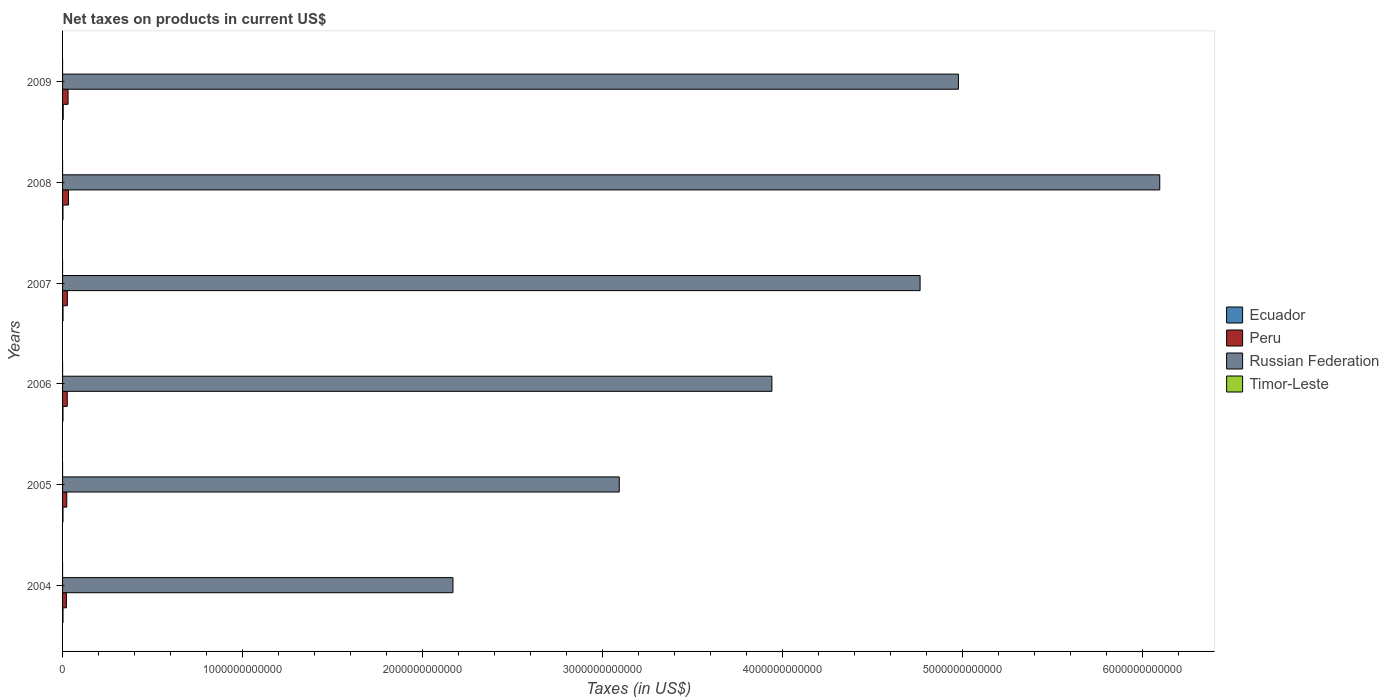How many different coloured bars are there?
Provide a succinct answer. 4. Are the number of bars per tick equal to the number of legend labels?
Give a very brief answer. No. How many bars are there on the 4th tick from the top?
Offer a very short reply. 3. How many bars are there on the 1st tick from the bottom?
Provide a short and direct response. 4. In how many cases, is the number of bars for a given year not equal to the number of legend labels?
Keep it short and to the point. 3. What is the net taxes on products in Ecuador in 2008?
Provide a short and direct response. 2.21e+09. Across all years, what is the maximum net taxes on products in Timor-Leste?
Provide a succinct answer. 1.60e+07. Across all years, what is the minimum net taxes on products in Russian Federation?
Offer a very short reply. 2.17e+12. What is the total net taxes on products in Timor-Leste in the graph?
Ensure brevity in your answer.  3.70e+07. What is the difference between the net taxes on products in Russian Federation in 2004 and that in 2007?
Your answer should be very brief. -2.59e+12. What is the difference between the net taxes on products in Peru in 2004 and the net taxes on products in Ecuador in 2009?
Provide a succinct answer. 1.78e+1. What is the average net taxes on products in Ecuador per year?
Provide a succinct answer. 2.54e+09. In the year 2005, what is the difference between the net taxes on products in Ecuador and net taxes on products in Russian Federation?
Provide a succinct answer. -3.09e+12. In how many years, is the net taxes on products in Russian Federation greater than 6000000000000 US$?
Ensure brevity in your answer.  1. What is the ratio of the net taxes on products in Ecuador in 2006 to that in 2009?
Give a very brief answer. 0.66. What is the difference between the highest and the lowest net taxes on products in Ecuador?
Make the answer very short. 1.29e+09. Is it the case that in every year, the sum of the net taxes on products in Peru and net taxes on products in Russian Federation is greater than the net taxes on products in Ecuador?
Provide a short and direct response. Yes. How many bars are there?
Provide a short and direct response. 21. Are all the bars in the graph horizontal?
Provide a short and direct response. Yes. What is the difference between two consecutive major ticks on the X-axis?
Keep it short and to the point. 1.00e+12. Does the graph contain grids?
Keep it short and to the point. No. How many legend labels are there?
Your response must be concise. 4. How are the legend labels stacked?
Your answer should be very brief. Vertical. What is the title of the graph?
Your answer should be very brief. Net taxes on products in current US$. What is the label or title of the X-axis?
Give a very brief answer. Taxes (in US$). What is the Taxes (in US$) in Ecuador in 2004?
Provide a short and direct response. 2.39e+09. What is the Taxes (in US$) of Peru in 2004?
Give a very brief answer. 2.13e+1. What is the Taxes (in US$) of Russian Federation in 2004?
Offer a terse response. 2.17e+12. What is the Taxes (in US$) of Timor-Leste in 2004?
Provide a succinct answer. 1.60e+07. What is the Taxes (in US$) of Ecuador in 2005?
Keep it short and to the point. 2.30e+09. What is the Taxes (in US$) of Peru in 2005?
Your response must be concise. 2.33e+1. What is the Taxes (in US$) in Russian Federation in 2005?
Keep it short and to the point. 3.09e+12. What is the Taxes (in US$) in Timor-Leste in 2005?
Offer a terse response. 1.20e+07. What is the Taxes (in US$) of Ecuador in 2006?
Your answer should be very brief. 2.30e+09. What is the Taxes (in US$) of Peru in 2006?
Your answer should be compact. 2.60e+1. What is the Taxes (in US$) of Russian Federation in 2006?
Offer a terse response. 3.94e+12. What is the Taxes (in US$) of Ecuador in 2007?
Provide a succinct answer. 2.50e+09. What is the Taxes (in US$) of Peru in 2007?
Make the answer very short. 2.65e+1. What is the Taxes (in US$) of Russian Federation in 2007?
Offer a terse response. 4.76e+12. What is the Taxes (in US$) of Timor-Leste in 2007?
Give a very brief answer. 9.00e+06. What is the Taxes (in US$) of Ecuador in 2008?
Offer a very short reply. 2.21e+09. What is the Taxes (in US$) in Peru in 2008?
Give a very brief answer. 3.29e+1. What is the Taxes (in US$) in Russian Federation in 2008?
Your answer should be very brief. 6.09e+12. What is the Taxes (in US$) in Timor-Leste in 2008?
Your answer should be very brief. 0. What is the Taxes (in US$) of Ecuador in 2009?
Give a very brief answer. 3.51e+09. What is the Taxes (in US$) of Peru in 2009?
Offer a very short reply. 3.05e+1. What is the Taxes (in US$) in Russian Federation in 2009?
Offer a terse response. 4.98e+12. What is the Taxes (in US$) in Timor-Leste in 2009?
Your answer should be very brief. 0. Across all years, what is the maximum Taxes (in US$) in Ecuador?
Keep it short and to the point. 3.51e+09. Across all years, what is the maximum Taxes (in US$) of Peru?
Provide a succinct answer. 3.29e+1. Across all years, what is the maximum Taxes (in US$) in Russian Federation?
Provide a short and direct response. 6.09e+12. Across all years, what is the maximum Taxes (in US$) of Timor-Leste?
Keep it short and to the point. 1.60e+07. Across all years, what is the minimum Taxes (in US$) in Ecuador?
Provide a short and direct response. 2.21e+09. Across all years, what is the minimum Taxes (in US$) of Peru?
Your response must be concise. 2.13e+1. Across all years, what is the minimum Taxes (in US$) in Russian Federation?
Your answer should be compact. 2.17e+12. What is the total Taxes (in US$) of Ecuador in the graph?
Make the answer very short. 1.52e+1. What is the total Taxes (in US$) of Peru in the graph?
Make the answer very short. 1.61e+11. What is the total Taxes (in US$) of Russian Federation in the graph?
Offer a terse response. 2.50e+13. What is the total Taxes (in US$) of Timor-Leste in the graph?
Offer a very short reply. 3.70e+07. What is the difference between the Taxes (in US$) of Ecuador in 2004 and that in 2005?
Your answer should be very brief. 9.16e+07. What is the difference between the Taxes (in US$) of Peru in 2004 and that in 2005?
Your answer should be compact. -1.97e+09. What is the difference between the Taxes (in US$) of Russian Federation in 2004 and that in 2005?
Ensure brevity in your answer.  -9.24e+11. What is the difference between the Taxes (in US$) in Timor-Leste in 2004 and that in 2005?
Give a very brief answer. 4.00e+06. What is the difference between the Taxes (in US$) in Ecuador in 2004 and that in 2006?
Give a very brief answer. 8.86e+07. What is the difference between the Taxes (in US$) of Peru in 2004 and that in 2006?
Give a very brief answer. -4.66e+09. What is the difference between the Taxes (in US$) in Russian Federation in 2004 and that in 2006?
Your answer should be very brief. -1.77e+12. What is the difference between the Taxes (in US$) of Ecuador in 2004 and that in 2007?
Ensure brevity in your answer.  -1.03e+08. What is the difference between the Taxes (in US$) in Peru in 2004 and that in 2007?
Offer a terse response. -5.16e+09. What is the difference between the Taxes (in US$) in Russian Federation in 2004 and that in 2007?
Offer a terse response. -2.59e+12. What is the difference between the Taxes (in US$) in Ecuador in 2004 and that in 2008?
Offer a very short reply. 1.82e+08. What is the difference between the Taxes (in US$) of Peru in 2004 and that in 2008?
Give a very brief answer. -1.16e+1. What is the difference between the Taxes (in US$) of Russian Federation in 2004 and that in 2008?
Offer a terse response. -3.93e+12. What is the difference between the Taxes (in US$) in Ecuador in 2004 and that in 2009?
Offer a terse response. -1.11e+09. What is the difference between the Taxes (in US$) in Peru in 2004 and that in 2009?
Provide a short and direct response. -9.16e+09. What is the difference between the Taxes (in US$) in Russian Federation in 2004 and that in 2009?
Give a very brief answer. -2.81e+12. What is the difference between the Taxes (in US$) of Ecuador in 2005 and that in 2006?
Give a very brief answer. -2.96e+06. What is the difference between the Taxes (in US$) in Peru in 2005 and that in 2006?
Your answer should be compact. -2.69e+09. What is the difference between the Taxes (in US$) of Russian Federation in 2005 and that in 2006?
Offer a terse response. -8.48e+11. What is the difference between the Taxes (in US$) of Ecuador in 2005 and that in 2007?
Ensure brevity in your answer.  -1.95e+08. What is the difference between the Taxes (in US$) of Peru in 2005 and that in 2007?
Make the answer very short. -3.19e+09. What is the difference between the Taxes (in US$) of Russian Federation in 2005 and that in 2007?
Ensure brevity in your answer.  -1.67e+12. What is the difference between the Taxes (in US$) of Ecuador in 2005 and that in 2008?
Make the answer very short. 9.02e+07. What is the difference between the Taxes (in US$) of Peru in 2005 and that in 2008?
Keep it short and to the point. -9.61e+09. What is the difference between the Taxes (in US$) of Russian Federation in 2005 and that in 2008?
Offer a very short reply. -3.00e+12. What is the difference between the Taxes (in US$) in Ecuador in 2005 and that in 2009?
Make the answer very short. -1.20e+09. What is the difference between the Taxes (in US$) of Peru in 2005 and that in 2009?
Your answer should be compact. -7.19e+09. What is the difference between the Taxes (in US$) of Russian Federation in 2005 and that in 2009?
Keep it short and to the point. -1.88e+12. What is the difference between the Taxes (in US$) in Ecuador in 2006 and that in 2007?
Give a very brief answer. -1.92e+08. What is the difference between the Taxes (in US$) in Peru in 2006 and that in 2007?
Your answer should be very brief. -4.99e+08. What is the difference between the Taxes (in US$) in Russian Federation in 2006 and that in 2007?
Offer a terse response. -8.23e+11. What is the difference between the Taxes (in US$) in Ecuador in 2006 and that in 2008?
Ensure brevity in your answer.  9.32e+07. What is the difference between the Taxes (in US$) of Peru in 2006 and that in 2008?
Your response must be concise. -6.92e+09. What is the difference between the Taxes (in US$) of Russian Federation in 2006 and that in 2008?
Your answer should be very brief. -2.15e+12. What is the difference between the Taxes (in US$) in Ecuador in 2006 and that in 2009?
Make the answer very short. -1.20e+09. What is the difference between the Taxes (in US$) in Peru in 2006 and that in 2009?
Offer a very short reply. -4.50e+09. What is the difference between the Taxes (in US$) in Russian Federation in 2006 and that in 2009?
Offer a terse response. -1.04e+12. What is the difference between the Taxes (in US$) of Ecuador in 2007 and that in 2008?
Provide a short and direct response. 2.85e+08. What is the difference between the Taxes (in US$) of Peru in 2007 and that in 2008?
Keep it short and to the point. -6.42e+09. What is the difference between the Taxes (in US$) of Russian Federation in 2007 and that in 2008?
Offer a very short reply. -1.33e+12. What is the difference between the Taxes (in US$) of Ecuador in 2007 and that in 2009?
Your response must be concise. -1.01e+09. What is the difference between the Taxes (in US$) of Peru in 2007 and that in 2009?
Your response must be concise. -4.00e+09. What is the difference between the Taxes (in US$) in Russian Federation in 2007 and that in 2009?
Your answer should be compact. -2.13e+11. What is the difference between the Taxes (in US$) in Ecuador in 2008 and that in 2009?
Your answer should be compact. -1.29e+09. What is the difference between the Taxes (in US$) of Peru in 2008 and that in 2009?
Offer a very short reply. 2.42e+09. What is the difference between the Taxes (in US$) of Russian Federation in 2008 and that in 2009?
Keep it short and to the point. 1.12e+12. What is the difference between the Taxes (in US$) of Ecuador in 2004 and the Taxes (in US$) of Peru in 2005?
Provide a succinct answer. -2.09e+1. What is the difference between the Taxes (in US$) in Ecuador in 2004 and the Taxes (in US$) in Russian Federation in 2005?
Give a very brief answer. -3.09e+12. What is the difference between the Taxes (in US$) in Ecuador in 2004 and the Taxes (in US$) in Timor-Leste in 2005?
Give a very brief answer. 2.38e+09. What is the difference between the Taxes (in US$) of Peru in 2004 and the Taxes (in US$) of Russian Federation in 2005?
Provide a succinct answer. -3.07e+12. What is the difference between the Taxes (in US$) of Peru in 2004 and the Taxes (in US$) of Timor-Leste in 2005?
Make the answer very short. 2.13e+1. What is the difference between the Taxes (in US$) in Russian Federation in 2004 and the Taxes (in US$) in Timor-Leste in 2005?
Make the answer very short. 2.17e+12. What is the difference between the Taxes (in US$) in Ecuador in 2004 and the Taxes (in US$) in Peru in 2006?
Give a very brief answer. -2.36e+1. What is the difference between the Taxes (in US$) of Ecuador in 2004 and the Taxes (in US$) of Russian Federation in 2006?
Your response must be concise. -3.94e+12. What is the difference between the Taxes (in US$) in Peru in 2004 and the Taxes (in US$) in Russian Federation in 2006?
Provide a short and direct response. -3.92e+12. What is the difference between the Taxes (in US$) of Ecuador in 2004 and the Taxes (in US$) of Peru in 2007?
Provide a succinct answer. -2.41e+1. What is the difference between the Taxes (in US$) in Ecuador in 2004 and the Taxes (in US$) in Russian Federation in 2007?
Provide a succinct answer. -4.76e+12. What is the difference between the Taxes (in US$) in Ecuador in 2004 and the Taxes (in US$) in Timor-Leste in 2007?
Offer a very short reply. 2.38e+09. What is the difference between the Taxes (in US$) in Peru in 2004 and the Taxes (in US$) in Russian Federation in 2007?
Your answer should be very brief. -4.74e+12. What is the difference between the Taxes (in US$) in Peru in 2004 and the Taxes (in US$) in Timor-Leste in 2007?
Offer a very short reply. 2.13e+1. What is the difference between the Taxes (in US$) in Russian Federation in 2004 and the Taxes (in US$) in Timor-Leste in 2007?
Make the answer very short. 2.17e+12. What is the difference between the Taxes (in US$) of Ecuador in 2004 and the Taxes (in US$) of Peru in 2008?
Keep it short and to the point. -3.05e+1. What is the difference between the Taxes (in US$) of Ecuador in 2004 and the Taxes (in US$) of Russian Federation in 2008?
Your response must be concise. -6.09e+12. What is the difference between the Taxes (in US$) in Peru in 2004 and the Taxes (in US$) in Russian Federation in 2008?
Your response must be concise. -6.07e+12. What is the difference between the Taxes (in US$) of Ecuador in 2004 and the Taxes (in US$) of Peru in 2009?
Provide a succinct answer. -2.81e+1. What is the difference between the Taxes (in US$) in Ecuador in 2004 and the Taxes (in US$) in Russian Federation in 2009?
Provide a succinct answer. -4.97e+12. What is the difference between the Taxes (in US$) of Peru in 2004 and the Taxes (in US$) of Russian Federation in 2009?
Your answer should be compact. -4.95e+12. What is the difference between the Taxes (in US$) of Ecuador in 2005 and the Taxes (in US$) of Peru in 2006?
Provide a short and direct response. -2.37e+1. What is the difference between the Taxes (in US$) in Ecuador in 2005 and the Taxes (in US$) in Russian Federation in 2006?
Provide a succinct answer. -3.94e+12. What is the difference between the Taxes (in US$) of Peru in 2005 and the Taxes (in US$) of Russian Federation in 2006?
Your answer should be very brief. -3.92e+12. What is the difference between the Taxes (in US$) of Ecuador in 2005 and the Taxes (in US$) of Peru in 2007?
Provide a succinct answer. -2.42e+1. What is the difference between the Taxes (in US$) of Ecuador in 2005 and the Taxes (in US$) of Russian Federation in 2007?
Give a very brief answer. -4.76e+12. What is the difference between the Taxes (in US$) of Ecuador in 2005 and the Taxes (in US$) of Timor-Leste in 2007?
Give a very brief answer. 2.29e+09. What is the difference between the Taxes (in US$) in Peru in 2005 and the Taxes (in US$) in Russian Federation in 2007?
Make the answer very short. -4.74e+12. What is the difference between the Taxes (in US$) in Peru in 2005 and the Taxes (in US$) in Timor-Leste in 2007?
Provide a short and direct response. 2.33e+1. What is the difference between the Taxes (in US$) in Russian Federation in 2005 and the Taxes (in US$) in Timor-Leste in 2007?
Offer a terse response. 3.09e+12. What is the difference between the Taxes (in US$) of Ecuador in 2005 and the Taxes (in US$) of Peru in 2008?
Offer a very short reply. -3.06e+1. What is the difference between the Taxes (in US$) of Ecuador in 2005 and the Taxes (in US$) of Russian Federation in 2008?
Make the answer very short. -6.09e+12. What is the difference between the Taxes (in US$) in Peru in 2005 and the Taxes (in US$) in Russian Federation in 2008?
Offer a very short reply. -6.07e+12. What is the difference between the Taxes (in US$) of Ecuador in 2005 and the Taxes (in US$) of Peru in 2009?
Ensure brevity in your answer.  -2.82e+1. What is the difference between the Taxes (in US$) in Ecuador in 2005 and the Taxes (in US$) in Russian Federation in 2009?
Your answer should be compact. -4.97e+12. What is the difference between the Taxes (in US$) of Peru in 2005 and the Taxes (in US$) of Russian Federation in 2009?
Keep it short and to the point. -4.95e+12. What is the difference between the Taxes (in US$) in Ecuador in 2006 and the Taxes (in US$) in Peru in 2007?
Your answer should be compact. -2.42e+1. What is the difference between the Taxes (in US$) in Ecuador in 2006 and the Taxes (in US$) in Russian Federation in 2007?
Ensure brevity in your answer.  -4.76e+12. What is the difference between the Taxes (in US$) in Ecuador in 2006 and the Taxes (in US$) in Timor-Leste in 2007?
Make the answer very short. 2.30e+09. What is the difference between the Taxes (in US$) of Peru in 2006 and the Taxes (in US$) of Russian Federation in 2007?
Your answer should be compact. -4.74e+12. What is the difference between the Taxes (in US$) in Peru in 2006 and the Taxes (in US$) in Timor-Leste in 2007?
Keep it short and to the point. 2.60e+1. What is the difference between the Taxes (in US$) in Russian Federation in 2006 and the Taxes (in US$) in Timor-Leste in 2007?
Make the answer very short. 3.94e+12. What is the difference between the Taxes (in US$) of Ecuador in 2006 and the Taxes (in US$) of Peru in 2008?
Your answer should be compact. -3.06e+1. What is the difference between the Taxes (in US$) in Ecuador in 2006 and the Taxes (in US$) in Russian Federation in 2008?
Your response must be concise. -6.09e+12. What is the difference between the Taxes (in US$) of Peru in 2006 and the Taxes (in US$) of Russian Federation in 2008?
Provide a short and direct response. -6.07e+12. What is the difference between the Taxes (in US$) of Ecuador in 2006 and the Taxes (in US$) of Peru in 2009?
Offer a very short reply. -2.82e+1. What is the difference between the Taxes (in US$) in Ecuador in 2006 and the Taxes (in US$) in Russian Federation in 2009?
Keep it short and to the point. -4.97e+12. What is the difference between the Taxes (in US$) of Peru in 2006 and the Taxes (in US$) of Russian Federation in 2009?
Your answer should be compact. -4.95e+12. What is the difference between the Taxes (in US$) in Ecuador in 2007 and the Taxes (in US$) in Peru in 2008?
Your response must be concise. -3.04e+1. What is the difference between the Taxes (in US$) in Ecuador in 2007 and the Taxes (in US$) in Russian Federation in 2008?
Ensure brevity in your answer.  -6.09e+12. What is the difference between the Taxes (in US$) of Peru in 2007 and the Taxes (in US$) of Russian Federation in 2008?
Your response must be concise. -6.07e+12. What is the difference between the Taxes (in US$) in Ecuador in 2007 and the Taxes (in US$) in Peru in 2009?
Ensure brevity in your answer.  -2.80e+1. What is the difference between the Taxes (in US$) of Ecuador in 2007 and the Taxes (in US$) of Russian Federation in 2009?
Your response must be concise. -4.97e+12. What is the difference between the Taxes (in US$) in Peru in 2007 and the Taxes (in US$) in Russian Federation in 2009?
Give a very brief answer. -4.95e+12. What is the difference between the Taxes (in US$) in Ecuador in 2008 and the Taxes (in US$) in Peru in 2009?
Your answer should be compact. -2.83e+1. What is the difference between the Taxes (in US$) of Ecuador in 2008 and the Taxes (in US$) of Russian Federation in 2009?
Give a very brief answer. -4.97e+12. What is the difference between the Taxes (in US$) of Peru in 2008 and the Taxes (in US$) of Russian Federation in 2009?
Offer a very short reply. -4.94e+12. What is the average Taxes (in US$) in Ecuador per year?
Make the answer very short. 2.54e+09. What is the average Taxes (in US$) in Peru per year?
Provide a succinct answer. 2.68e+1. What is the average Taxes (in US$) in Russian Federation per year?
Provide a succinct answer. 4.17e+12. What is the average Taxes (in US$) in Timor-Leste per year?
Offer a very short reply. 6.17e+06. In the year 2004, what is the difference between the Taxes (in US$) in Ecuador and Taxes (in US$) in Peru?
Give a very brief answer. -1.90e+1. In the year 2004, what is the difference between the Taxes (in US$) in Ecuador and Taxes (in US$) in Russian Federation?
Your response must be concise. -2.17e+12. In the year 2004, what is the difference between the Taxes (in US$) in Ecuador and Taxes (in US$) in Timor-Leste?
Make the answer very short. 2.38e+09. In the year 2004, what is the difference between the Taxes (in US$) of Peru and Taxes (in US$) of Russian Federation?
Make the answer very short. -2.15e+12. In the year 2004, what is the difference between the Taxes (in US$) of Peru and Taxes (in US$) of Timor-Leste?
Keep it short and to the point. 2.13e+1. In the year 2004, what is the difference between the Taxes (in US$) of Russian Federation and Taxes (in US$) of Timor-Leste?
Ensure brevity in your answer.  2.17e+12. In the year 2005, what is the difference between the Taxes (in US$) in Ecuador and Taxes (in US$) in Peru?
Your answer should be very brief. -2.10e+1. In the year 2005, what is the difference between the Taxes (in US$) in Ecuador and Taxes (in US$) in Russian Federation?
Make the answer very short. -3.09e+12. In the year 2005, what is the difference between the Taxes (in US$) of Ecuador and Taxes (in US$) of Timor-Leste?
Offer a very short reply. 2.29e+09. In the year 2005, what is the difference between the Taxes (in US$) of Peru and Taxes (in US$) of Russian Federation?
Keep it short and to the point. -3.07e+12. In the year 2005, what is the difference between the Taxes (in US$) of Peru and Taxes (in US$) of Timor-Leste?
Offer a terse response. 2.33e+1. In the year 2005, what is the difference between the Taxes (in US$) in Russian Federation and Taxes (in US$) in Timor-Leste?
Provide a succinct answer. 3.09e+12. In the year 2006, what is the difference between the Taxes (in US$) in Ecuador and Taxes (in US$) in Peru?
Keep it short and to the point. -2.37e+1. In the year 2006, what is the difference between the Taxes (in US$) in Ecuador and Taxes (in US$) in Russian Federation?
Provide a short and direct response. -3.94e+12. In the year 2006, what is the difference between the Taxes (in US$) in Peru and Taxes (in US$) in Russian Federation?
Provide a succinct answer. -3.91e+12. In the year 2007, what is the difference between the Taxes (in US$) of Ecuador and Taxes (in US$) of Peru?
Your response must be concise. -2.40e+1. In the year 2007, what is the difference between the Taxes (in US$) in Ecuador and Taxes (in US$) in Russian Federation?
Your answer should be very brief. -4.76e+12. In the year 2007, what is the difference between the Taxes (in US$) of Ecuador and Taxes (in US$) of Timor-Leste?
Ensure brevity in your answer.  2.49e+09. In the year 2007, what is the difference between the Taxes (in US$) of Peru and Taxes (in US$) of Russian Federation?
Offer a very short reply. -4.74e+12. In the year 2007, what is the difference between the Taxes (in US$) in Peru and Taxes (in US$) in Timor-Leste?
Provide a succinct answer. 2.65e+1. In the year 2007, what is the difference between the Taxes (in US$) in Russian Federation and Taxes (in US$) in Timor-Leste?
Provide a succinct answer. 4.76e+12. In the year 2008, what is the difference between the Taxes (in US$) of Ecuador and Taxes (in US$) of Peru?
Keep it short and to the point. -3.07e+1. In the year 2008, what is the difference between the Taxes (in US$) in Ecuador and Taxes (in US$) in Russian Federation?
Your response must be concise. -6.09e+12. In the year 2008, what is the difference between the Taxes (in US$) in Peru and Taxes (in US$) in Russian Federation?
Offer a very short reply. -6.06e+12. In the year 2009, what is the difference between the Taxes (in US$) in Ecuador and Taxes (in US$) in Peru?
Your answer should be compact. -2.70e+1. In the year 2009, what is the difference between the Taxes (in US$) in Ecuador and Taxes (in US$) in Russian Federation?
Give a very brief answer. -4.97e+12. In the year 2009, what is the difference between the Taxes (in US$) of Peru and Taxes (in US$) of Russian Federation?
Your response must be concise. -4.95e+12. What is the ratio of the Taxes (in US$) of Ecuador in 2004 to that in 2005?
Provide a succinct answer. 1.04. What is the ratio of the Taxes (in US$) of Peru in 2004 to that in 2005?
Your response must be concise. 0.92. What is the ratio of the Taxes (in US$) of Russian Federation in 2004 to that in 2005?
Provide a succinct answer. 0.7. What is the ratio of the Taxes (in US$) of Timor-Leste in 2004 to that in 2005?
Keep it short and to the point. 1.33. What is the ratio of the Taxes (in US$) of Ecuador in 2004 to that in 2006?
Provide a short and direct response. 1.04. What is the ratio of the Taxes (in US$) of Peru in 2004 to that in 2006?
Provide a succinct answer. 0.82. What is the ratio of the Taxes (in US$) in Russian Federation in 2004 to that in 2006?
Offer a terse response. 0.55. What is the ratio of the Taxes (in US$) of Ecuador in 2004 to that in 2007?
Offer a very short reply. 0.96. What is the ratio of the Taxes (in US$) in Peru in 2004 to that in 2007?
Give a very brief answer. 0.81. What is the ratio of the Taxes (in US$) in Russian Federation in 2004 to that in 2007?
Provide a short and direct response. 0.46. What is the ratio of the Taxes (in US$) of Timor-Leste in 2004 to that in 2007?
Offer a terse response. 1.78. What is the ratio of the Taxes (in US$) of Ecuador in 2004 to that in 2008?
Your answer should be compact. 1.08. What is the ratio of the Taxes (in US$) in Peru in 2004 to that in 2008?
Offer a terse response. 0.65. What is the ratio of the Taxes (in US$) in Russian Federation in 2004 to that in 2008?
Your answer should be compact. 0.36. What is the ratio of the Taxes (in US$) of Ecuador in 2004 to that in 2009?
Provide a succinct answer. 0.68. What is the ratio of the Taxes (in US$) in Peru in 2004 to that in 2009?
Your answer should be very brief. 0.7. What is the ratio of the Taxes (in US$) in Russian Federation in 2004 to that in 2009?
Keep it short and to the point. 0.44. What is the ratio of the Taxes (in US$) of Ecuador in 2005 to that in 2006?
Keep it short and to the point. 1. What is the ratio of the Taxes (in US$) in Peru in 2005 to that in 2006?
Ensure brevity in your answer.  0.9. What is the ratio of the Taxes (in US$) in Russian Federation in 2005 to that in 2006?
Ensure brevity in your answer.  0.78. What is the ratio of the Taxes (in US$) in Ecuador in 2005 to that in 2007?
Your response must be concise. 0.92. What is the ratio of the Taxes (in US$) of Peru in 2005 to that in 2007?
Your response must be concise. 0.88. What is the ratio of the Taxes (in US$) of Russian Federation in 2005 to that in 2007?
Offer a terse response. 0.65. What is the ratio of the Taxes (in US$) in Timor-Leste in 2005 to that in 2007?
Give a very brief answer. 1.33. What is the ratio of the Taxes (in US$) of Ecuador in 2005 to that in 2008?
Keep it short and to the point. 1.04. What is the ratio of the Taxes (in US$) in Peru in 2005 to that in 2008?
Your response must be concise. 0.71. What is the ratio of the Taxes (in US$) of Russian Federation in 2005 to that in 2008?
Give a very brief answer. 0.51. What is the ratio of the Taxes (in US$) in Ecuador in 2005 to that in 2009?
Provide a short and direct response. 0.66. What is the ratio of the Taxes (in US$) in Peru in 2005 to that in 2009?
Make the answer very short. 0.76. What is the ratio of the Taxes (in US$) in Russian Federation in 2005 to that in 2009?
Keep it short and to the point. 0.62. What is the ratio of the Taxes (in US$) of Peru in 2006 to that in 2007?
Your response must be concise. 0.98. What is the ratio of the Taxes (in US$) in Russian Federation in 2006 to that in 2007?
Offer a very short reply. 0.83. What is the ratio of the Taxes (in US$) in Ecuador in 2006 to that in 2008?
Provide a short and direct response. 1.04. What is the ratio of the Taxes (in US$) of Peru in 2006 to that in 2008?
Keep it short and to the point. 0.79. What is the ratio of the Taxes (in US$) of Russian Federation in 2006 to that in 2008?
Ensure brevity in your answer.  0.65. What is the ratio of the Taxes (in US$) in Ecuador in 2006 to that in 2009?
Keep it short and to the point. 0.66. What is the ratio of the Taxes (in US$) in Peru in 2006 to that in 2009?
Your answer should be compact. 0.85. What is the ratio of the Taxes (in US$) of Russian Federation in 2006 to that in 2009?
Make the answer very short. 0.79. What is the ratio of the Taxes (in US$) of Ecuador in 2007 to that in 2008?
Offer a terse response. 1.13. What is the ratio of the Taxes (in US$) of Peru in 2007 to that in 2008?
Give a very brief answer. 0.81. What is the ratio of the Taxes (in US$) in Russian Federation in 2007 to that in 2008?
Give a very brief answer. 0.78. What is the ratio of the Taxes (in US$) in Ecuador in 2007 to that in 2009?
Make the answer very short. 0.71. What is the ratio of the Taxes (in US$) of Peru in 2007 to that in 2009?
Your response must be concise. 0.87. What is the ratio of the Taxes (in US$) in Russian Federation in 2007 to that in 2009?
Provide a short and direct response. 0.96. What is the ratio of the Taxes (in US$) of Ecuador in 2008 to that in 2009?
Provide a succinct answer. 0.63. What is the ratio of the Taxes (in US$) of Peru in 2008 to that in 2009?
Provide a succinct answer. 1.08. What is the ratio of the Taxes (in US$) of Russian Federation in 2008 to that in 2009?
Give a very brief answer. 1.22. What is the difference between the highest and the second highest Taxes (in US$) in Ecuador?
Give a very brief answer. 1.01e+09. What is the difference between the highest and the second highest Taxes (in US$) in Peru?
Provide a short and direct response. 2.42e+09. What is the difference between the highest and the second highest Taxes (in US$) of Russian Federation?
Provide a short and direct response. 1.12e+12. What is the difference between the highest and the second highest Taxes (in US$) of Timor-Leste?
Your answer should be compact. 4.00e+06. What is the difference between the highest and the lowest Taxes (in US$) of Ecuador?
Make the answer very short. 1.29e+09. What is the difference between the highest and the lowest Taxes (in US$) in Peru?
Ensure brevity in your answer.  1.16e+1. What is the difference between the highest and the lowest Taxes (in US$) in Russian Federation?
Give a very brief answer. 3.93e+12. What is the difference between the highest and the lowest Taxes (in US$) in Timor-Leste?
Your answer should be very brief. 1.60e+07. 